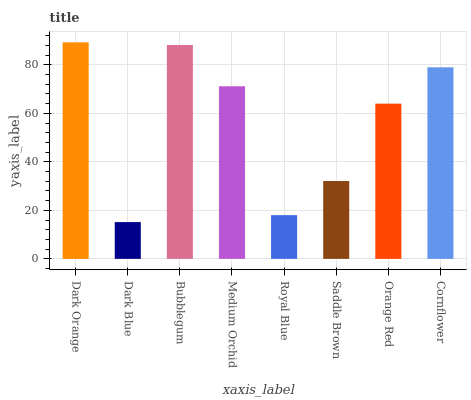Is Dark Blue the minimum?
Answer yes or no. Yes. Is Dark Orange the maximum?
Answer yes or no. Yes. Is Bubblegum the minimum?
Answer yes or no. No. Is Bubblegum the maximum?
Answer yes or no. No. Is Bubblegum greater than Dark Blue?
Answer yes or no. Yes. Is Dark Blue less than Bubblegum?
Answer yes or no. Yes. Is Dark Blue greater than Bubblegum?
Answer yes or no. No. Is Bubblegum less than Dark Blue?
Answer yes or no. No. Is Medium Orchid the high median?
Answer yes or no. Yes. Is Orange Red the low median?
Answer yes or no. Yes. Is Bubblegum the high median?
Answer yes or no. No. Is Saddle Brown the low median?
Answer yes or no. No. 